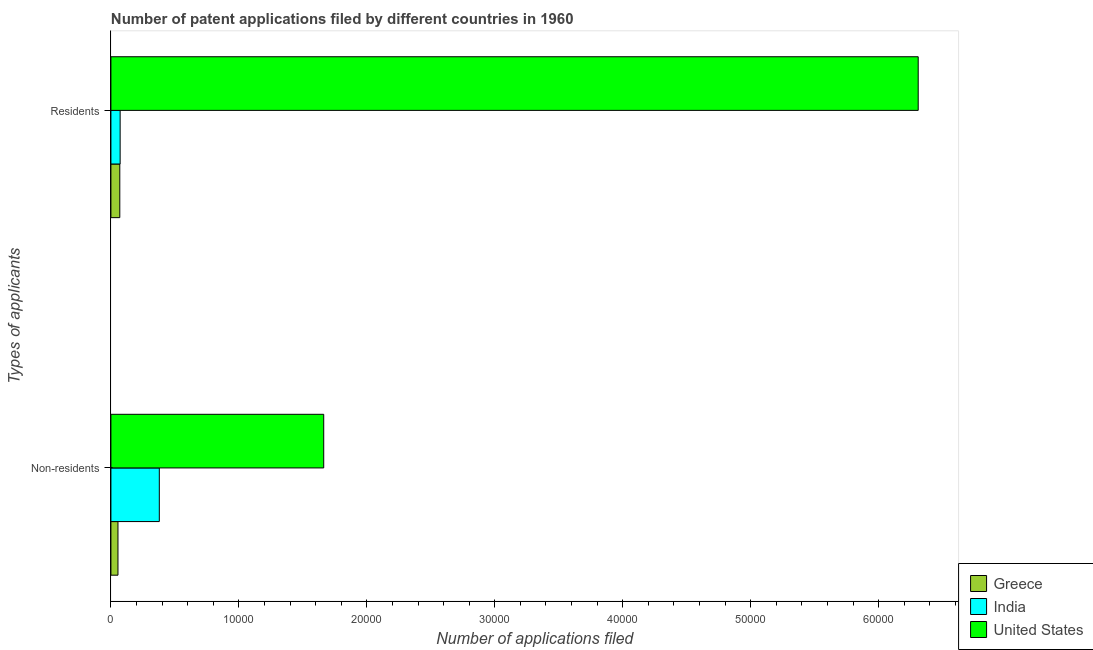How many different coloured bars are there?
Your answer should be very brief. 3. How many groups of bars are there?
Your answer should be very brief. 2. How many bars are there on the 1st tick from the bottom?
Keep it short and to the point. 3. What is the label of the 1st group of bars from the top?
Your answer should be very brief. Residents. What is the number of patent applications by residents in Greece?
Offer a terse response. 694. Across all countries, what is the maximum number of patent applications by non residents?
Your answer should be compact. 1.66e+04. Across all countries, what is the minimum number of patent applications by residents?
Provide a succinct answer. 694. In which country was the number of patent applications by non residents maximum?
Make the answer very short. United States. In which country was the number of patent applications by residents minimum?
Offer a terse response. Greece. What is the total number of patent applications by non residents in the graph?
Your response must be concise. 2.10e+04. What is the difference between the number of patent applications by non residents in United States and that in India?
Ensure brevity in your answer.  1.28e+04. What is the difference between the number of patent applications by residents in Greece and the number of patent applications by non residents in United States?
Give a very brief answer. -1.59e+04. What is the average number of patent applications by residents per country?
Make the answer very short. 2.15e+04. What is the difference between the number of patent applications by non residents and number of patent applications by residents in India?
Your answer should be compact. 3061. What is the ratio of the number of patent applications by residents in United States to that in Greece?
Your answer should be very brief. 90.91. In how many countries, is the number of patent applications by non residents greater than the average number of patent applications by non residents taken over all countries?
Your answer should be compact. 1. What does the 3rd bar from the top in Residents represents?
Provide a short and direct response. Greece. What does the 1st bar from the bottom in Residents represents?
Your answer should be compact. Greece. What is the difference between two consecutive major ticks on the X-axis?
Make the answer very short. 10000. Are the values on the major ticks of X-axis written in scientific E-notation?
Offer a terse response. No. Does the graph contain grids?
Make the answer very short. No. Where does the legend appear in the graph?
Offer a terse response. Bottom right. What is the title of the graph?
Provide a short and direct response. Number of patent applications filed by different countries in 1960. Does "Gambia, The" appear as one of the legend labels in the graph?
Give a very brief answer. No. What is the label or title of the X-axis?
Your response must be concise. Number of applications filed. What is the label or title of the Y-axis?
Provide a short and direct response. Types of applicants. What is the Number of applications filed in Greece in Non-residents?
Your answer should be compact. 551. What is the Number of applications filed in India in Non-residents?
Give a very brief answer. 3782. What is the Number of applications filed of United States in Non-residents?
Make the answer very short. 1.66e+04. What is the Number of applications filed in Greece in Residents?
Keep it short and to the point. 694. What is the Number of applications filed of India in Residents?
Give a very brief answer. 721. What is the Number of applications filed of United States in Residents?
Your response must be concise. 6.31e+04. Across all Types of applicants, what is the maximum Number of applications filed in Greece?
Ensure brevity in your answer.  694. Across all Types of applicants, what is the maximum Number of applications filed of India?
Provide a short and direct response. 3782. Across all Types of applicants, what is the maximum Number of applications filed in United States?
Your answer should be compact. 6.31e+04. Across all Types of applicants, what is the minimum Number of applications filed in Greece?
Your answer should be very brief. 551. Across all Types of applicants, what is the minimum Number of applications filed in India?
Keep it short and to the point. 721. Across all Types of applicants, what is the minimum Number of applications filed in United States?
Make the answer very short. 1.66e+04. What is the total Number of applications filed in Greece in the graph?
Give a very brief answer. 1245. What is the total Number of applications filed of India in the graph?
Provide a short and direct response. 4503. What is the total Number of applications filed of United States in the graph?
Offer a terse response. 7.97e+04. What is the difference between the Number of applications filed of Greece in Non-residents and that in Residents?
Keep it short and to the point. -143. What is the difference between the Number of applications filed in India in Non-residents and that in Residents?
Provide a short and direct response. 3061. What is the difference between the Number of applications filed in United States in Non-residents and that in Residents?
Ensure brevity in your answer.  -4.65e+04. What is the difference between the Number of applications filed in Greece in Non-residents and the Number of applications filed in India in Residents?
Keep it short and to the point. -170. What is the difference between the Number of applications filed of Greece in Non-residents and the Number of applications filed of United States in Residents?
Your answer should be compact. -6.25e+04. What is the difference between the Number of applications filed in India in Non-residents and the Number of applications filed in United States in Residents?
Your answer should be very brief. -5.93e+04. What is the average Number of applications filed of Greece per Types of applicants?
Keep it short and to the point. 622.5. What is the average Number of applications filed of India per Types of applicants?
Make the answer very short. 2251.5. What is the average Number of applications filed of United States per Types of applicants?
Ensure brevity in your answer.  3.99e+04. What is the difference between the Number of applications filed in Greece and Number of applications filed in India in Non-residents?
Make the answer very short. -3231. What is the difference between the Number of applications filed in Greece and Number of applications filed in United States in Non-residents?
Offer a terse response. -1.61e+04. What is the difference between the Number of applications filed of India and Number of applications filed of United States in Non-residents?
Keep it short and to the point. -1.28e+04. What is the difference between the Number of applications filed in Greece and Number of applications filed in India in Residents?
Give a very brief answer. -27. What is the difference between the Number of applications filed in Greece and Number of applications filed in United States in Residents?
Provide a short and direct response. -6.24e+04. What is the difference between the Number of applications filed of India and Number of applications filed of United States in Residents?
Make the answer very short. -6.24e+04. What is the ratio of the Number of applications filed in Greece in Non-residents to that in Residents?
Give a very brief answer. 0.79. What is the ratio of the Number of applications filed of India in Non-residents to that in Residents?
Give a very brief answer. 5.25. What is the ratio of the Number of applications filed of United States in Non-residents to that in Residents?
Make the answer very short. 0.26. What is the difference between the highest and the second highest Number of applications filed in Greece?
Offer a terse response. 143. What is the difference between the highest and the second highest Number of applications filed of India?
Provide a succinct answer. 3061. What is the difference between the highest and the second highest Number of applications filed in United States?
Your answer should be compact. 4.65e+04. What is the difference between the highest and the lowest Number of applications filed in Greece?
Your answer should be compact. 143. What is the difference between the highest and the lowest Number of applications filed of India?
Your response must be concise. 3061. What is the difference between the highest and the lowest Number of applications filed in United States?
Your response must be concise. 4.65e+04. 